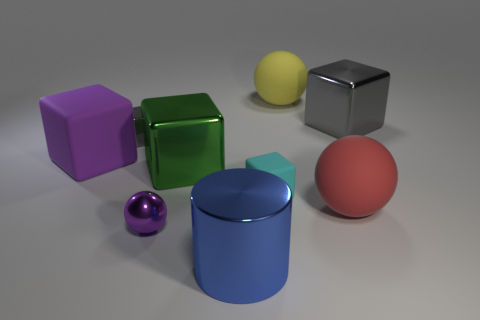There is a ball that is both behind the purple metal ball and to the left of the big red matte sphere; what size is it?
Keep it short and to the point. Large. What is the color of the big metal cylinder?
Offer a terse response. Blue. How many small green cylinders are there?
Offer a very short reply. 0. What number of big rubber things are the same color as the tiny shiny ball?
Your response must be concise. 1. There is a big metal thing that is behind the big purple thing; is its shape the same as the tiny shiny object that is in front of the green metallic block?
Give a very brief answer. No. There is a big matte sphere in front of the thing to the left of the small metal object behind the big green metal thing; what is its color?
Offer a terse response. Red. There is a big shiny cube in front of the tiny metal block; what color is it?
Offer a terse response. Green. What color is the other sphere that is the same size as the red ball?
Your answer should be very brief. Yellow. Is the yellow rubber ball the same size as the cyan rubber cube?
Ensure brevity in your answer.  No. How many shiny things are in front of the green block?
Your answer should be very brief. 2. 